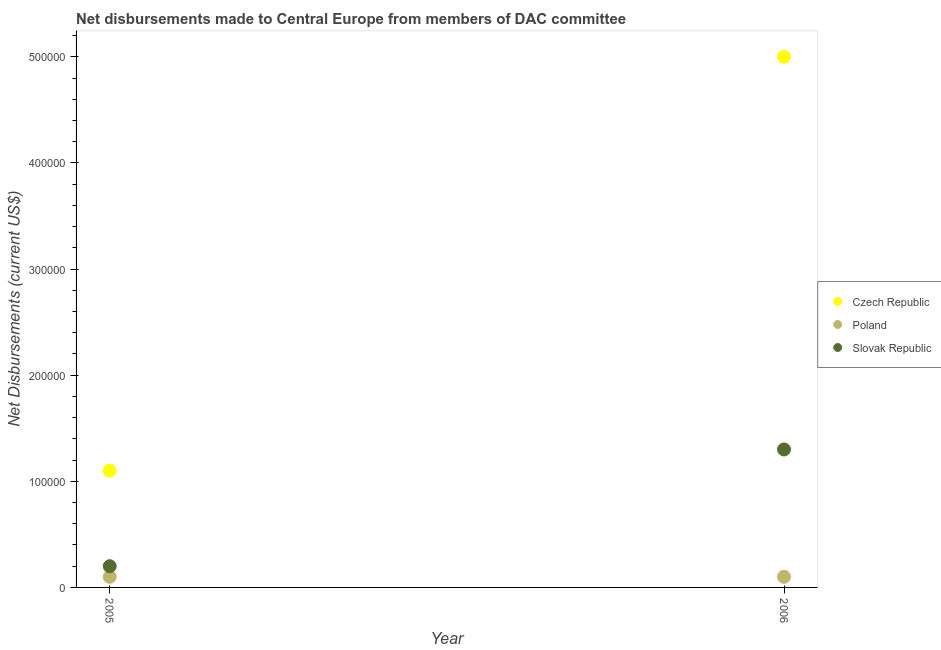Is the number of dotlines equal to the number of legend labels?
Give a very brief answer. Yes. What is the net disbursements made by czech republic in 2005?
Provide a short and direct response. 1.10e+05. Across all years, what is the maximum net disbursements made by czech republic?
Give a very brief answer. 5.00e+05. Across all years, what is the minimum net disbursements made by czech republic?
Offer a terse response. 1.10e+05. In which year was the net disbursements made by poland maximum?
Keep it short and to the point. 2005. What is the total net disbursements made by czech republic in the graph?
Your response must be concise. 6.10e+05. What is the difference between the net disbursements made by slovak republic in 2005 and that in 2006?
Your answer should be compact. -1.10e+05. What is the difference between the net disbursements made by poland in 2006 and the net disbursements made by slovak republic in 2005?
Your answer should be compact. -10000. What is the average net disbursements made by czech republic per year?
Offer a terse response. 3.05e+05. In the year 2006, what is the difference between the net disbursements made by poland and net disbursements made by czech republic?
Give a very brief answer. -4.90e+05. What is the ratio of the net disbursements made by slovak republic in 2005 to that in 2006?
Give a very brief answer. 0.15. Is the net disbursements made by czech republic in 2005 less than that in 2006?
Give a very brief answer. Yes. In how many years, is the net disbursements made by slovak republic greater than the average net disbursements made by slovak republic taken over all years?
Provide a short and direct response. 1. Is the net disbursements made by poland strictly less than the net disbursements made by slovak republic over the years?
Your answer should be compact. Yes. How many years are there in the graph?
Offer a terse response. 2. What is the difference between two consecutive major ticks on the Y-axis?
Provide a short and direct response. 1.00e+05. Are the values on the major ticks of Y-axis written in scientific E-notation?
Ensure brevity in your answer.  No. Does the graph contain any zero values?
Offer a terse response. No. Does the graph contain grids?
Give a very brief answer. No. Where does the legend appear in the graph?
Offer a very short reply. Center right. How many legend labels are there?
Keep it short and to the point. 3. What is the title of the graph?
Your answer should be very brief. Net disbursements made to Central Europe from members of DAC committee. What is the label or title of the X-axis?
Keep it short and to the point. Year. What is the label or title of the Y-axis?
Keep it short and to the point. Net Disbursements (current US$). What is the Net Disbursements (current US$) of Czech Republic in 2005?
Ensure brevity in your answer.  1.10e+05. What is the Net Disbursements (current US$) in Slovak Republic in 2006?
Your answer should be very brief. 1.30e+05. Across all years, what is the maximum Net Disbursements (current US$) of Czech Republic?
Ensure brevity in your answer.  5.00e+05. What is the total Net Disbursements (current US$) of Poland in the graph?
Offer a terse response. 2.00e+04. What is the difference between the Net Disbursements (current US$) of Czech Republic in 2005 and that in 2006?
Keep it short and to the point. -3.90e+05. What is the difference between the Net Disbursements (current US$) in Poland in 2005 and that in 2006?
Your answer should be very brief. 0. What is the average Net Disbursements (current US$) in Czech Republic per year?
Offer a very short reply. 3.05e+05. What is the average Net Disbursements (current US$) in Poland per year?
Your response must be concise. 10000. What is the average Net Disbursements (current US$) in Slovak Republic per year?
Make the answer very short. 7.50e+04. In the year 2005, what is the difference between the Net Disbursements (current US$) of Czech Republic and Net Disbursements (current US$) of Poland?
Make the answer very short. 1.00e+05. In the year 2005, what is the difference between the Net Disbursements (current US$) in Czech Republic and Net Disbursements (current US$) in Slovak Republic?
Your response must be concise. 9.00e+04. In the year 2005, what is the difference between the Net Disbursements (current US$) of Poland and Net Disbursements (current US$) of Slovak Republic?
Ensure brevity in your answer.  -10000. What is the ratio of the Net Disbursements (current US$) of Czech Republic in 2005 to that in 2006?
Provide a short and direct response. 0.22. What is the ratio of the Net Disbursements (current US$) in Slovak Republic in 2005 to that in 2006?
Give a very brief answer. 0.15. What is the difference between the highest and the second highest Net Disbursements (current US$) in Slovak Republic?
Provide a succinct answer. 1.10e+05. 